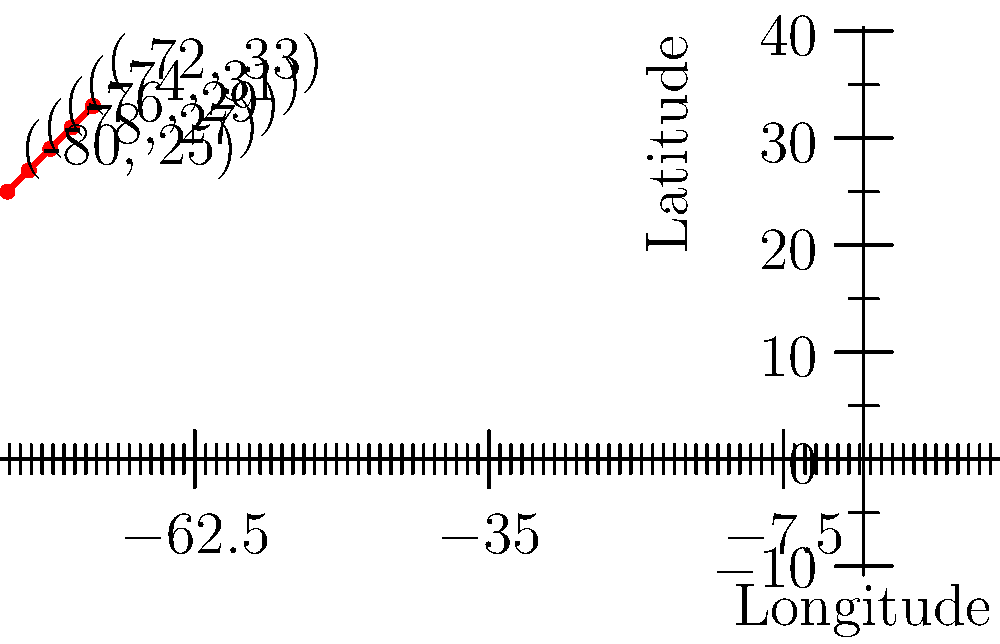As a volunteer monitoring hurricane trajectories, you've plotted the positions of a hurricane over the past 5 days. The coordinates (longitude, latitude) are shown on the map. Using this data, determine the hurricane's average speed in degrees per day, assuming it maintains a constant velocity. Round your answer to two decimal places. To solve this problem, we'll follow these steps:

1. Calculate the total distance traveled:
   - Start point: $(-80, 25)$
   - End point: $(-72, 33)$
   - Distance formula: $d = \sqrt{(\Delta x)^2 + (\Delta y)^2}$
   - $d = \sqrt{((-72) - (-80))^2 + (33 - 25)^2}$
   - $d = \sqrt{8^2 + 8^2} = \sqrt{128} = 8\sqrt{2}$ degrees

2. Calculate the time elapsed:
   - The hurricane was tracked for 5 days

3. Calculate the average speed:
   - Speed = Distance / Time
   - $s = \frac{8\sqrt{2}}{5}$ degrees per day

4. Simplify and round to two decimal places:
   - $s = \frac{8\sqrt{2}}{5} \approx 2.26$ degrees per day
Answer: 2.26 degrees/day 